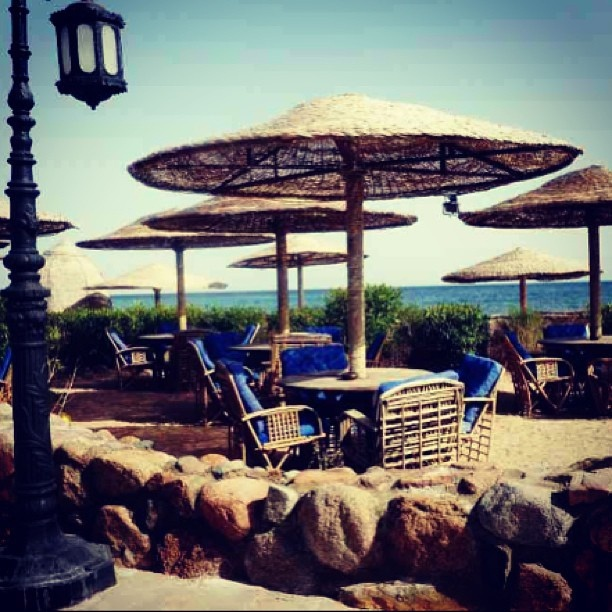Describe the objects in this image and their specific colors. I can see umbrella in teal, black, gray, lightyellow, and beige tones, chair in teal, black, navy, gray, and tan tones, chair in teal, black, tan, and gray tones, umbrella in teal, black, gray, and maroon tones, and umbrella in teal, black, tan, and gray tones in this image. 